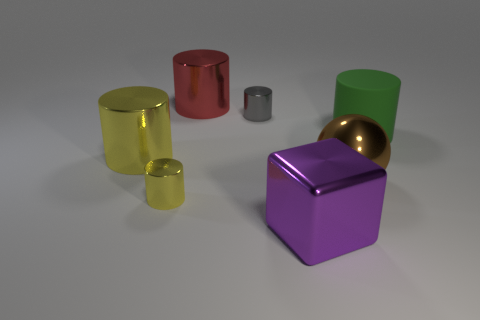Subtract all large yellow cylinders. How many cylinders are left? 4 Subtract all blue cylinders. Subtract all yellow cubes. How many cylinders are left? 5 Add 1 tiny gray shiny objects. How many objects exist? 8 Subtract all cubes. How many objects are left? 6 Subtract all tiny metallic cylinders. Subtract all small yellow things. How many objects are left? 4 Add 7 big purple objects. How many big purple objects are left? 8 Add 6 large purple metallic things. How many large purple metallic things exist? 7 Subtract 1 purple cubes. How many objects are left? 6 